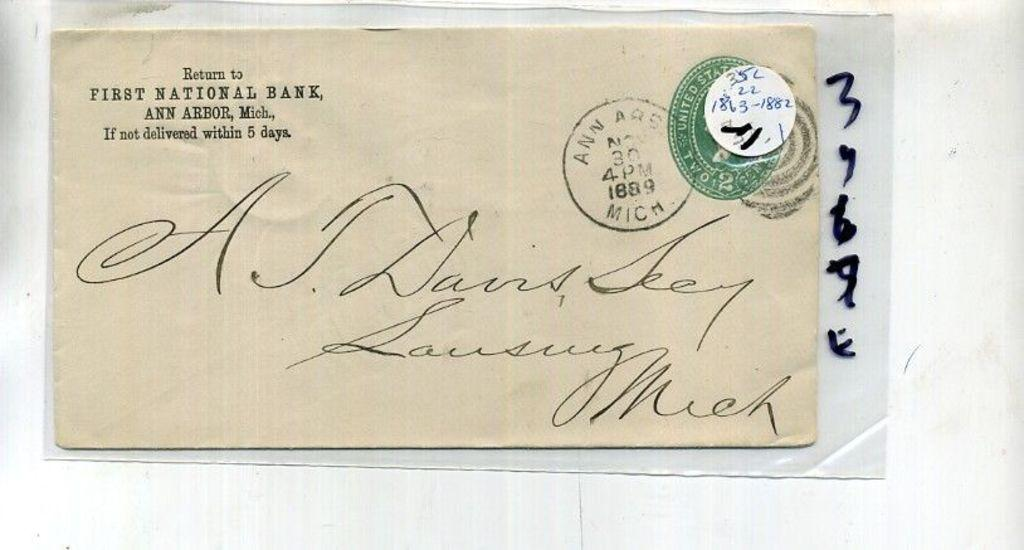<image>
Present a compact description of the photo's key features. an envelope that says 'return to first national bank' on the top left corner 